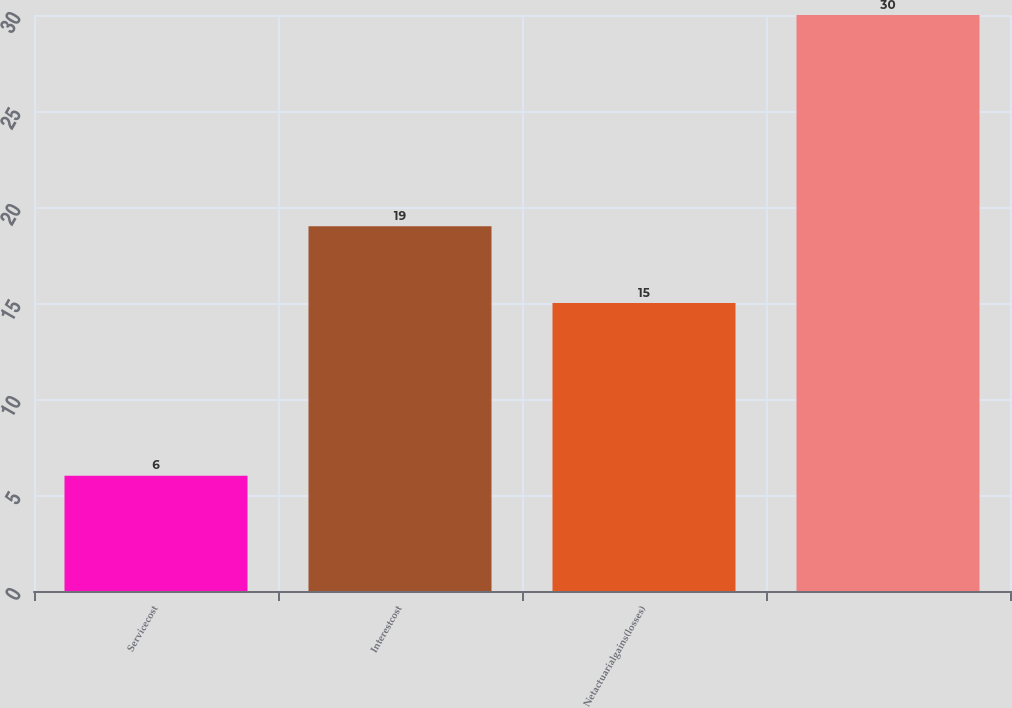<chart> <loc_0><loc_0><loc_500><loc_500><bar_chart><fcel>Servicecost<fcel>Interestcost<fcel>Netactuarialgains(losses)<fcel>Unnamed: 3<nl><fcel>6<fcel>19<fcel>15<fcel>30<nl></chart> 